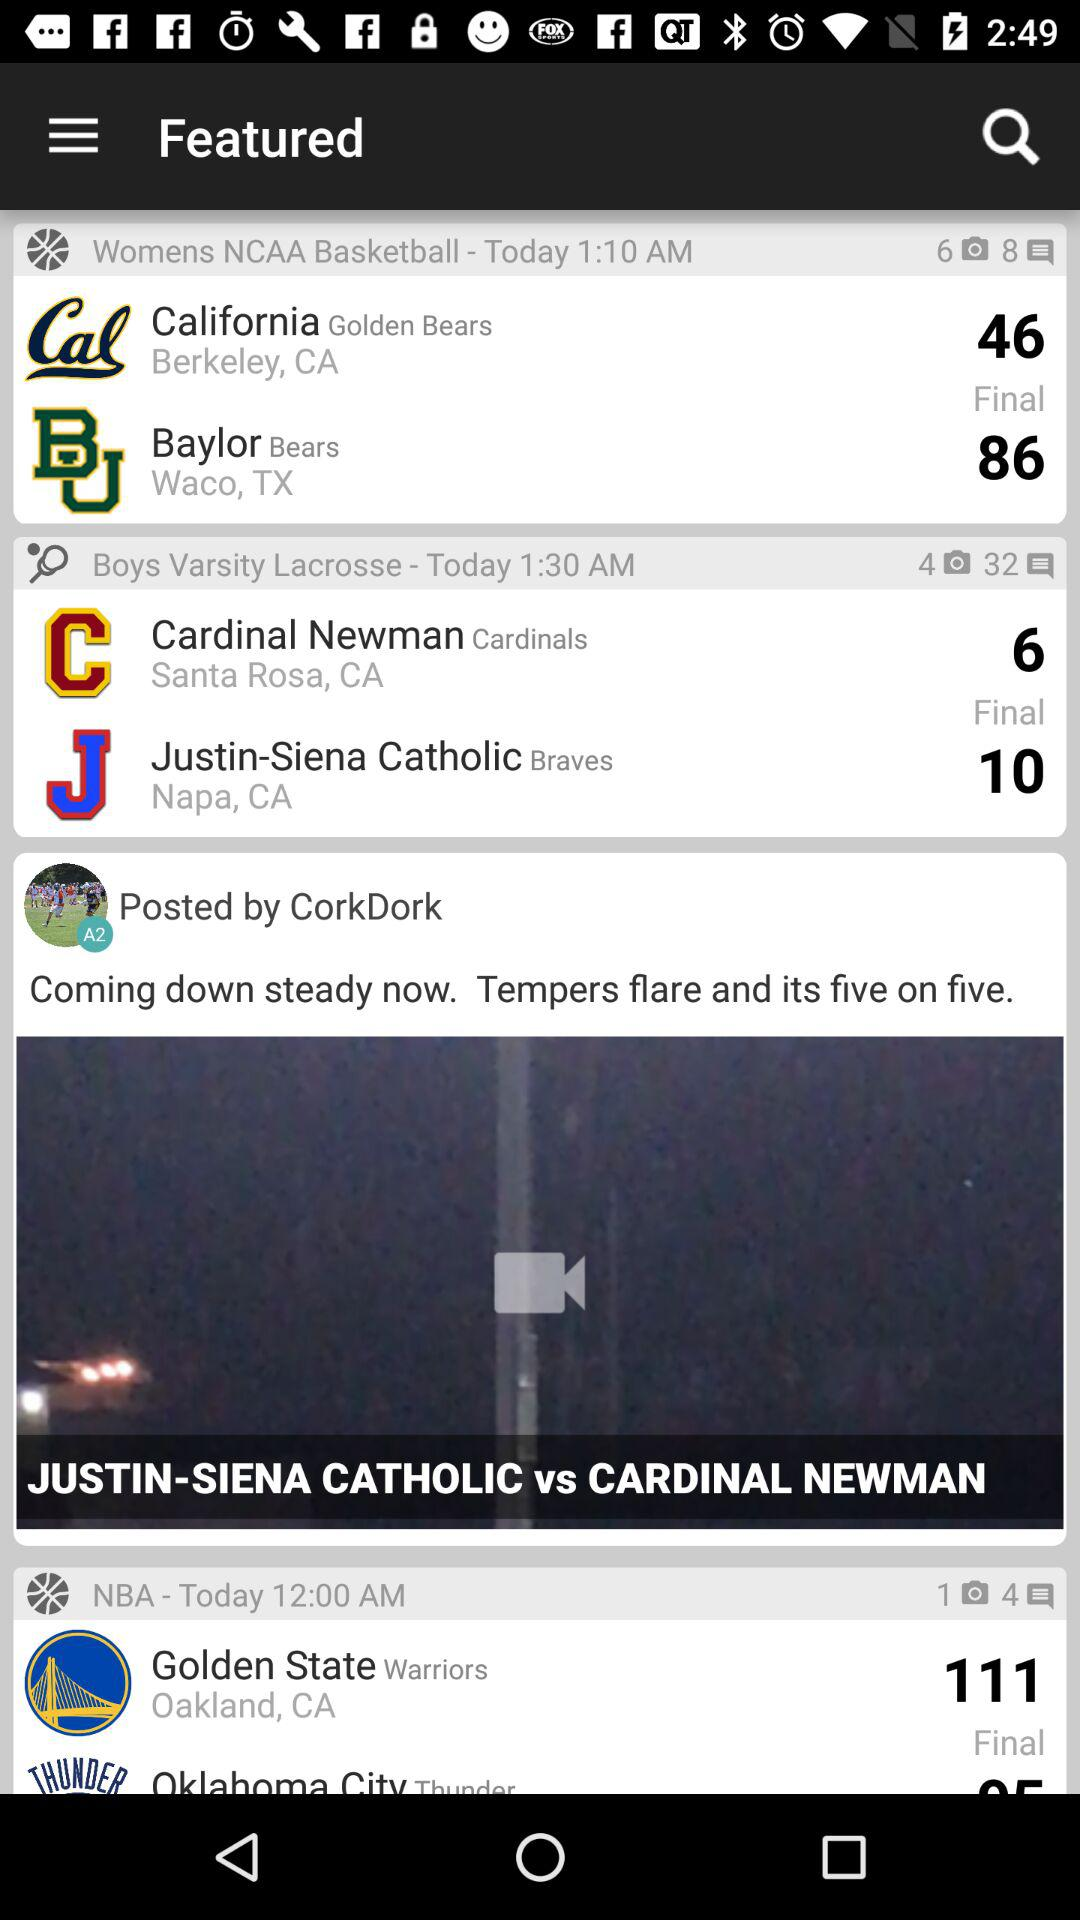What is the score of the Golden State Warriors? The score of the Golden State Warriors is 111. 